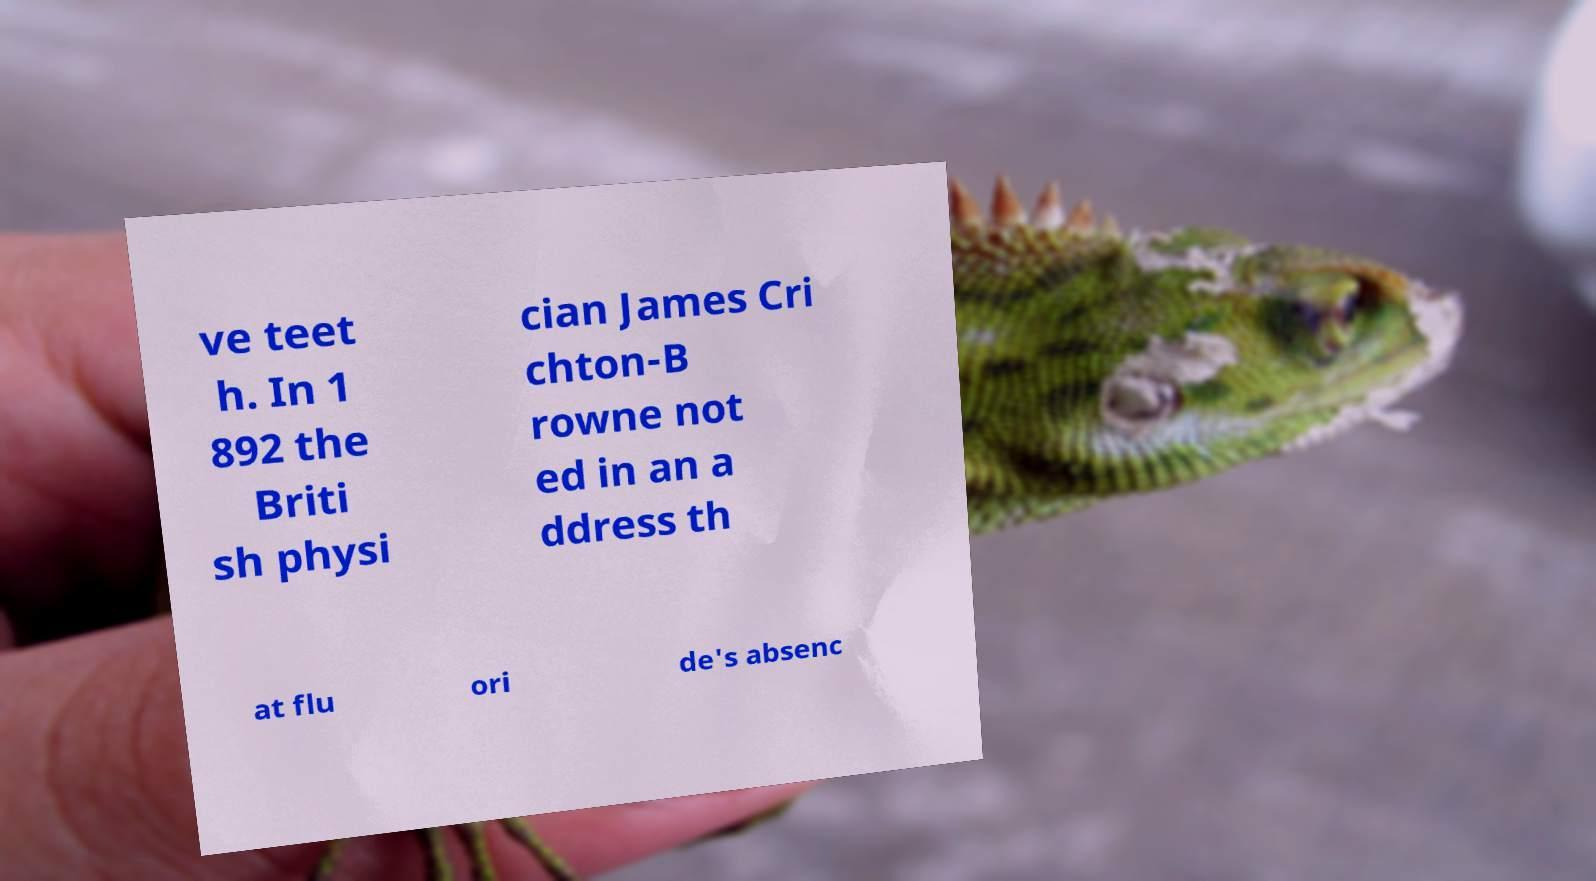Can you read and provide the text displayed in the image?This photo seems to have some interesting text. Can you extract and type it out for me? ve teet h. In 1 892 the Briti sh physi cian James Cri chton-B rowne not ed in an a ddress th at flu ori de's absenc 